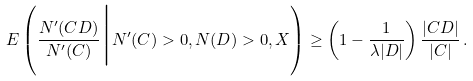<formula> <loc_0><loc_0><loc_500><loc_500>E \left ( \frac { N ^ { \prime } ( C D ) } { N ^ { \prime } ( C ) } \Big | N ^ { \prime } ( C ) > 0 , N ( D ) > 0 , X \right ) \geq \left ( 1 - \frac { 1 } { \lambda | D | } \right ) \frac { | C D | } { | C | } \, .</formula> 